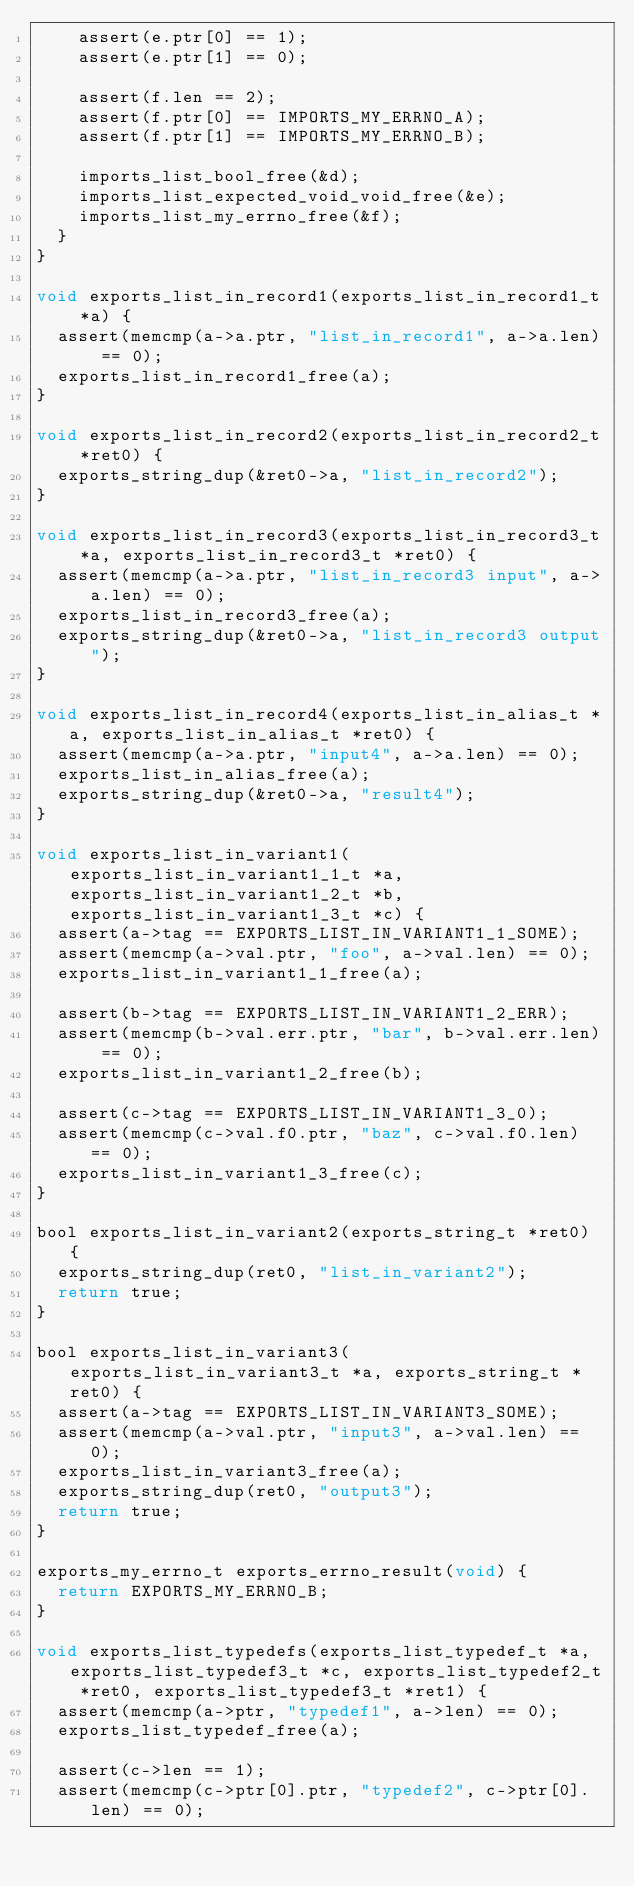Convert code to text. <code><loc_0><loc_0><loc_500><loc_500><_C_>    assert(e.ptr[0] == 1);
    assert(e.ptr[1] == 0);

    assert(f.len == 2);
    assert(f.ptr[0] == IMPORTS_MY_ERRNO_A);
    assert(f.ptr[1] == IMPORTS_MY_ERRNO_B);

    imports_list_bool_free(&d);
    imports_list_expected_void_void_free(&e);
    imports_list_my_errno_free(&f);
  }
}

void exports_list_in_record1(exports_list_in_record1_t *a) {
  assert(memcmp(a->a.ptr, "list_in_record1", a->a.len) == 0);
  exports_list_in_record1_free(a);
}

void exports_list_in_record2(exports_list_in_record2_t *ret0) {
  exports_string_dup(&ret0->a, "list_in_record2");
}

void exports_list_in_record3(exports_list_in_record3_t *a, exports_list_in_record3_t *ret0) {
  assert(memcmp(a->a.ptr, "list_in_record3 input", a->a.len) == 0);
  exports_list_in_record3_free(a);
  exports_string_dup(&ret0->a, "list_in_record3 output");
}

void exports_list_in_record4(exports_list_in_alias_t *a, exports_list_in_alias_t *ret0) {
  assert(memcmp(a->a.ptr, "input4", a->a.len) == 0);
  exports_list_in_alias_free(a);
  exports_string_dup(&ret0->a, "result4");
}

void exports_list_in_variant1(exports_list_in_variant1_1_t *a, exports_list_in_variant1_2_t *b, exports_list_in_variant1_3_t *c) {
  assert(a->tag == EXPORTS_LIST_IN_VARIANT1_1_SOME);
  assert(memcmp(a->val.ptr, "foo", a->val.len) == 0);
  exports_list_in_variant1_1_free(a);

  assert(b->tag == EXPORTS_LIST_IN_VARIANT1_2_ERR);
  assert(memcmp(b->val.err.ptr, "bar", b->val.err.len) == 0);
  exports_list_in_variant1_2_free(b);

  assert(c->tag == EXPORTS_LIST_IN_VARIANT1_3_0);
  assert(memcmp(c->val.f0.ptr, "baz", c->val.f0.len) == 0);
  exports_list_in_variant1_3_free(c);
}

bool exports_list_in_variant2(exports_string_t *ret0) {
  exports_string_dup(ret0, "list_in_variant2");
  return true;
}

bool exports_list_in_variant3(exports_list_in_variant3_t *a, exports_string_t *ret0) {
  assert(a->tag == EXPORTS_LIST_IN_VARIANT3_SOME);
  assert(memcmp(a->val.ptr, "input3", a->val.len) == 0);
  exports_list_in_variant3_free(a);
  exports_string_dup(ret0, "output3");
  return true;
}

exports_my_errno_t exports_errno_result(void) {
  return EXPORTS_MY_ERRNO_B;
}

void exports_list_typedefs(exports_list_typedef_t *a, exports_list_typedef3_t *c, exports_list_typedef2_t *ret0, exports_list_typedef3_t *ret1) {
  assert(memcmp(a->ptr, "typedef1", a->len) == 0);
  exports_list_typedef_free(a);

  assert(c->len == 1);
  assert(memcmp(c->ptr[0].ptr, "typedef2", c->ptr[0].len) == 0);</code> 